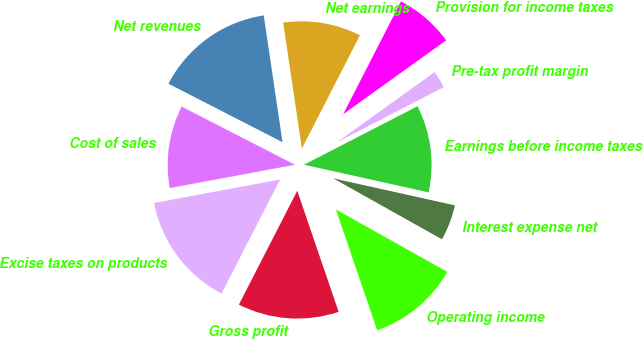Convert chart to OTSL. <chart><loc_0><loc_0><loc_500><loc_500><pie_chart><fcel>Net revenues<fcel>Cost of sales<fcel>Excise taxes on products<fcel>Gross profit<fcel>Operating income<fcel>Interest expense net<fcel>Earnings before income taxes<fcel>Pre-tax profit margin<fcel>Provision for income taxes<fcel>Net earnings<nl><fcel>15.12%<fcel>10.47%<fcel>14.53%<fcel>12.79%<fcel>11.63%<fcel>4.65%<fcel>11.05%<fcel>2.33%<fcel>7.56%<fcel>9.88%<nl></chart> 